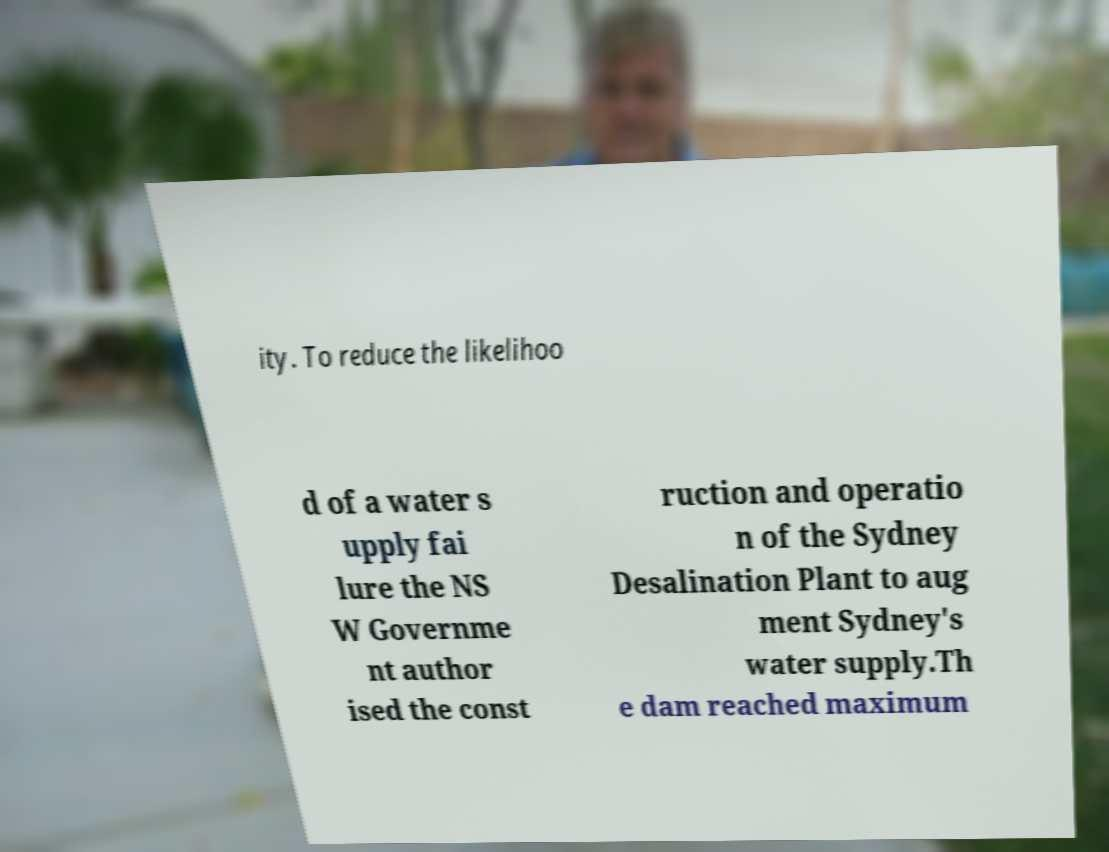Please identify and transcribe the text found in this image. ity. To reduce the likelihoo d of a water s upply fai lure the NS W Governme nt author ised the const ruction and operatio n of the Sydney Desalination Plant to aug ment Sydney's water supply.Th e dam reached maximum 